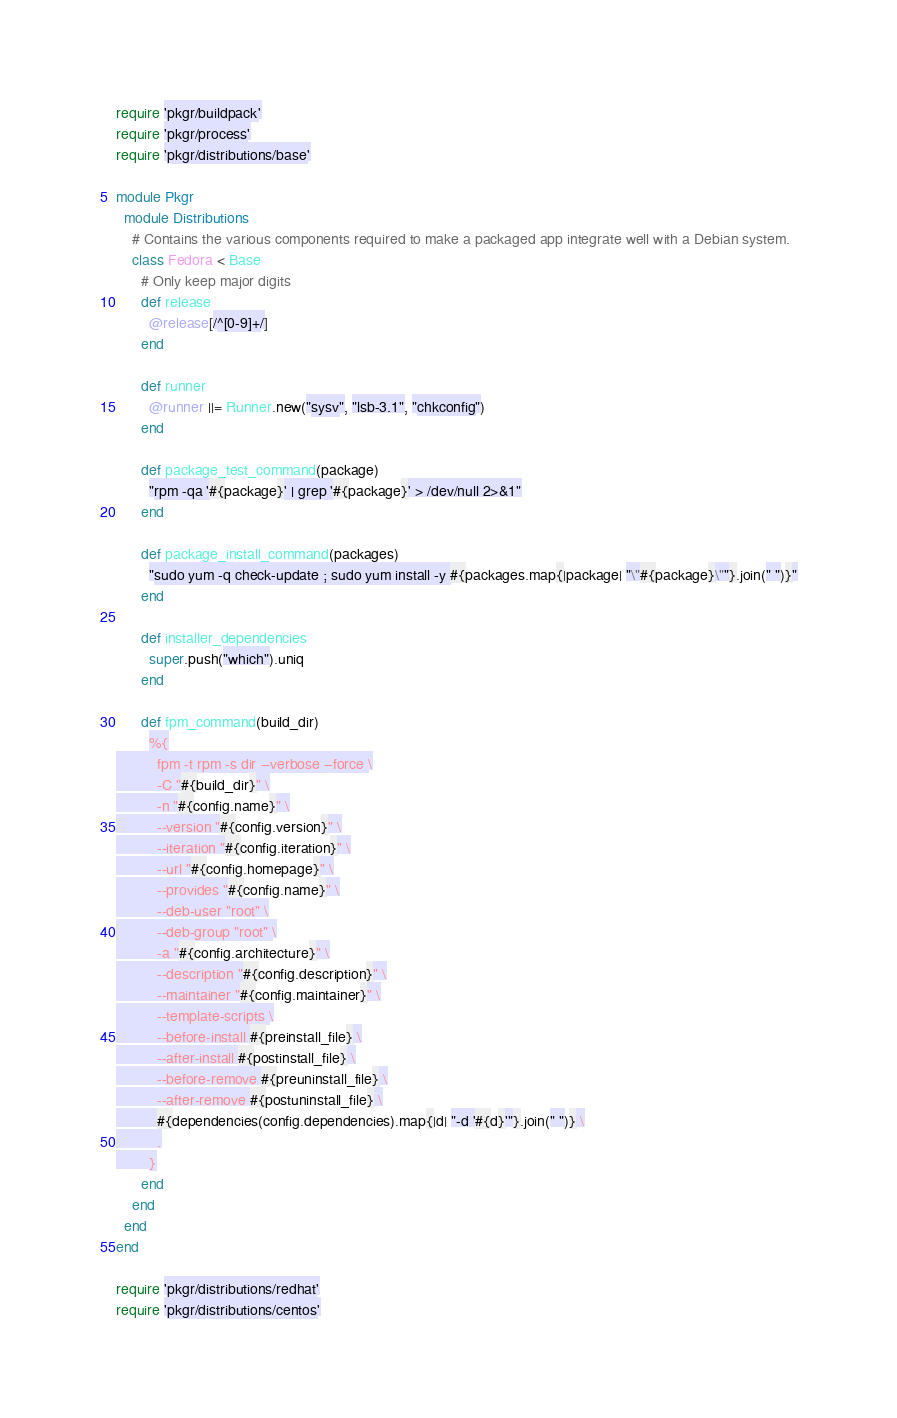Convert code to text. <code><loc_0><loc_0><loc_500><loc_500><_Ruby_>require 'pkgr/buildpack'
require 'pkgr/process'
require 'pkgr/distributions/base'

module Pkgr
  module Distributions
    # Contains the various components required to make a packaged app integrate well with a Debian system.
    class Fedora < Base
      # Only keep major digits
      def release
        @release[/^[0-9]+/]
      end

      def runner
        @runner ||= Runner.new("sysv", "lsb-3.1", "chkconfig")
      end

      def package_test_command(package)
        "rpm -qa '#{package}' | grep '#{package}' > /dev/null 2>&1"
      end

      def package_install_command(packages)
        "sudo yum -q check-update ; sudo yum install -y #{packages.map{|package| "\"#{package}\""}.join(" ")}"
      end

      def installer_dependencies
        super.push("which").uniq
      end

      def fpm_command(build_dir)
        %{
          fpm -t rpm -s dir --verbose --force \
          -C "#{build_dir}" \
          -n "#{config.name}" \
          --version "#{config.version}" \
          --iteration "#{config.iteration}" \
          --url "#{config.homepage}" \
          --provides "#{config.name}" \
          --deb-user "root" \
          --deb-group "root" \
          -a "#{config.architecture}" \
          --description "#{config.description}" \
          --maintainer "#{config.maintainer}" \
          --template-scripts \
          --before-install #{preinstall_file} \
          --after-install #{postinstall_file} \
          --before-remove #{preuninstall_file} \
          --after-remove #{postuninstall_file} \
          #{dependencies(config.dependencies).map{|d| "-d '#{d}'"}.join(" ")} \
          .
        }
      end
    end
  end
end

require 'pkgr/distributions/redhat'
require 'pkgr/distributions/centos'
</code> 